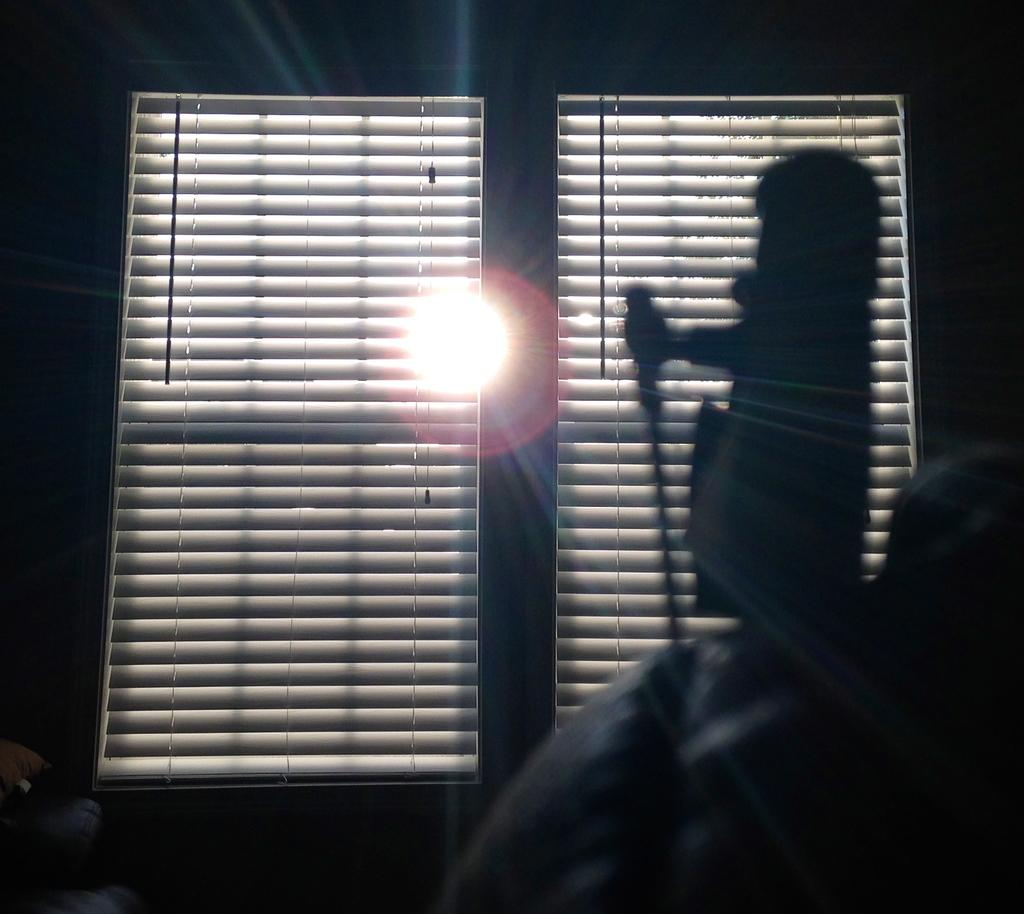What can be seen in the image that resembles a person? There is a shadow of a person in the image. What type of window covering is present in the image? There are window blinds in the image. What is the source of light in the image? The sun is visible in the image. What other objects can be seen in the image besides the shadow and window blinds? There are other objects in the image. What type of grain is being stored in the cheese in the image? There is no grain or cheese present in the image. 